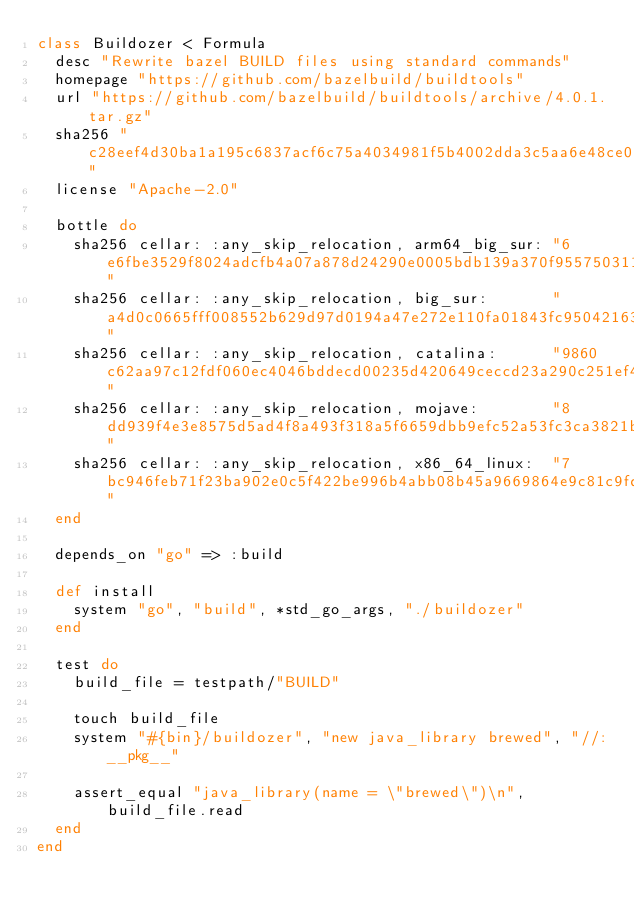<code> <loc_0><loc_0><loc_500><loc_500><_Ruby_>class Buildozer < Formula
  desc "Rewrite bazel BUILD files using standard commands"
  homepage "https://github.com/bazelbuild/buildtools"
  url "https://github.com/bazelbuild/buildtools/archive/4.0.1.tar.gz"
  sha256 "c28eef4d30ba1a195c6837acf6c75a4034981f5b4002dda3c5aa6e48ce023cf1"
  license "Apache-2.0"

  bottle do
    sha256 cellar: :any_skip_relocation, arm64_big_sur: "6e6fbe3529f8024adcfb4a07a878d24290e0005bdb139a370f955750311470c6"
    sha256 cellar: :any_skip_relocation, big_sur:       "a4d0c0665fff008552b629d97d0194a47e272e110fa01843fc95042163ae8d53"
    sha256 cellar: :any_skip_relocation, catalina:      "9860c62aa97c12fdf060ec4046bddecd00235d420649ceccd23a290c251ef4bd"
    sha256 cellar: :any_skip_relocation, mojave:        "8dd939f4e3e8575d5ad4f8a493f318a5f6659dbb9efc52a53fc3ca3821bd59e8"
    sha256 cellar: :any_skip_relocation, x86_64_linux:  "7bc946feb71f23ba902e0c5f422be996b4abb08b45a9669864e9c81c9fdade54"
  end

  depends_on "go" => :build

  def install
    system "go", "build", *std_go_args, "./buildozer"
  end

  test do
    build_file = testpath/"BUILD"

    touch build_file
    system "#{bin}/buildozer", "new java_library brewed", "//:__pkg__"

    assert_equal "java_library(name = \"brewed\")\n", build_file.read
  end
end
</code> 